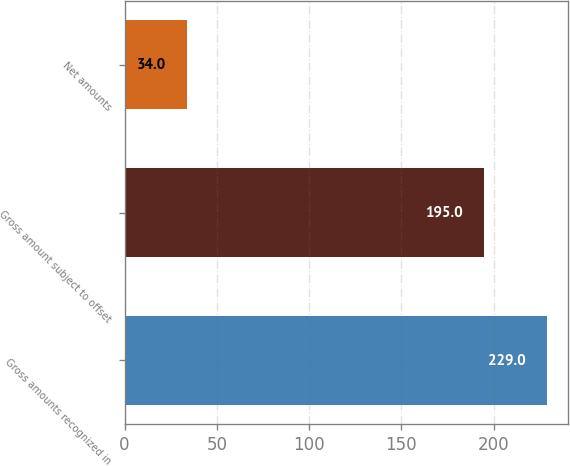Convert chart to OTSL. <chart><loc_0><loc_0><loc_500><loc_500><bar_chart><fcel>Gross amounts recognized in<fcel>Gross amount subject to offset<fcel>Net amounts<nl><fcel>229<fcel>195<fcel>34<nl></chart> 